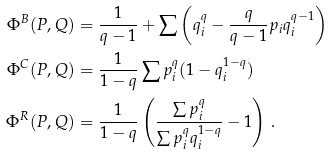<formula> <loc_0><loc_0><loc_500><loc_500>\Phi ^ { B } ( P , Q ) & = \frac { 1 } { q - 1 } + \sum \left ( q _ { i } ^ { q } - \frac { q } { q - 1 } p _ { i } q _ { i } ^ { q - 1 } \right ) \\ \Phi ^ { C } ( P , Q ) & = \frac { 1 } { 1 - q } \sum p _ { i } ^ { q } ( 1 - q _ { i } ^ { 1 - q } ) \\ \Phi ^ { R } ( P , Q ) & = \frac { 1 } { 1 - q } \left ( \frac { \sum p _ { i } ^ { q } } { \sum p _ { i } ^ { q } q _ { i } ^ { 1 - q } } - 1 \right ) \, .</formula> 